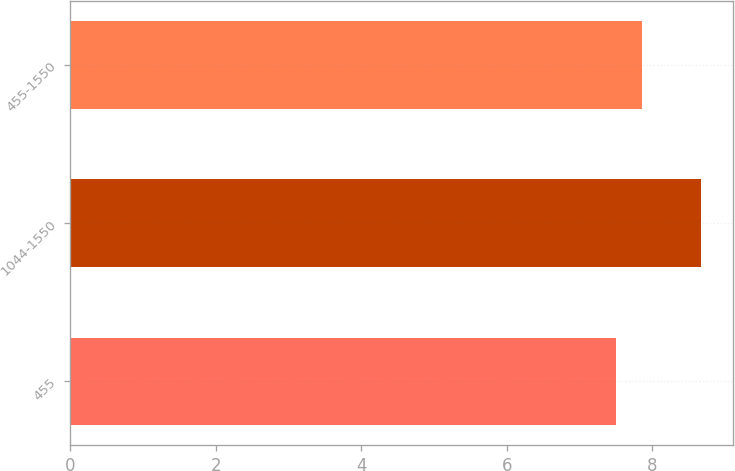<chart> <loc_0><loc_0><loc_500><loc_500><bar_chart><fcel>455<fcel>1044-1550<fcel>455-1550<nl><fcel>7.5<fcel>8.67<fcel>7.86<nl></chart> 